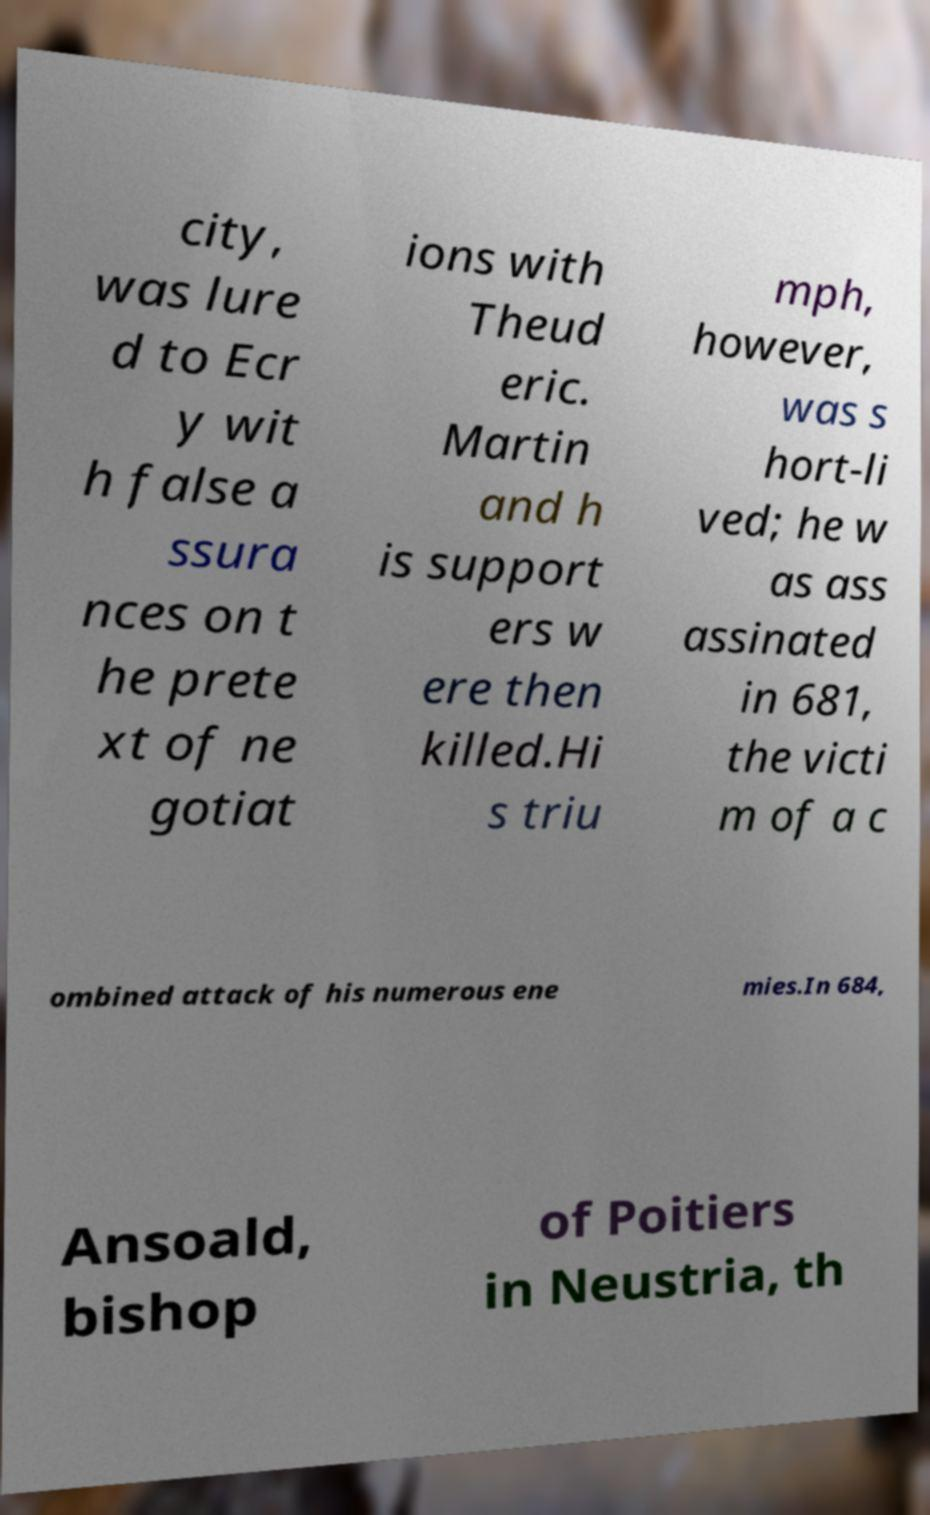Could you assist in decoding the text presented in this image and type it out clearly? city, was lure d to Ecr y wit h false a ssura nces on t he prete xt of ne gotiat ions with Theud eric. Martin and h is support ers w ere then killed.Hi s triu mph, however, was s hort-li ved; he w as ass assinated in 681, the victi m of a c ombined attack of his numerous ene mies.In 684, Ansoald, bishop of Poitiers in Neustria, th 